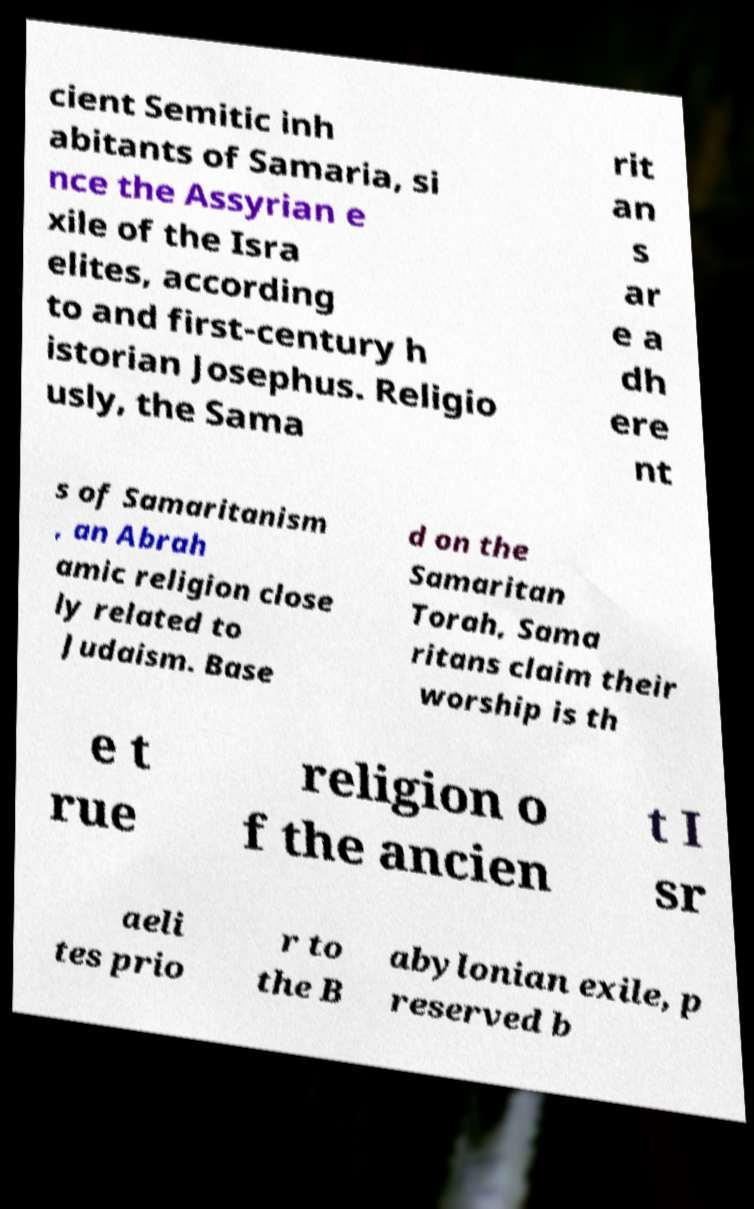Can you accurately transcribe the text from the provided image for me? cient Semitic inh abitants of Samaria, si nce the Assyrian e xile of the Isra elites, according to and first-century h istorian Josephus. Religio usly, the Sama rit an s ar e a dh ere nt s of Samaritanism , an Abrah amic religion close ly related to Judaism. Base d on the Samaritan Torah, Sama ritans claim their worship is th e t rue religion o f the ancien t I sr aeli tes prio r to the B abylonian exile, p reserved b 